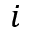<formula> <loc_0><loc_0><loc_500><loc_500>i</formula> 